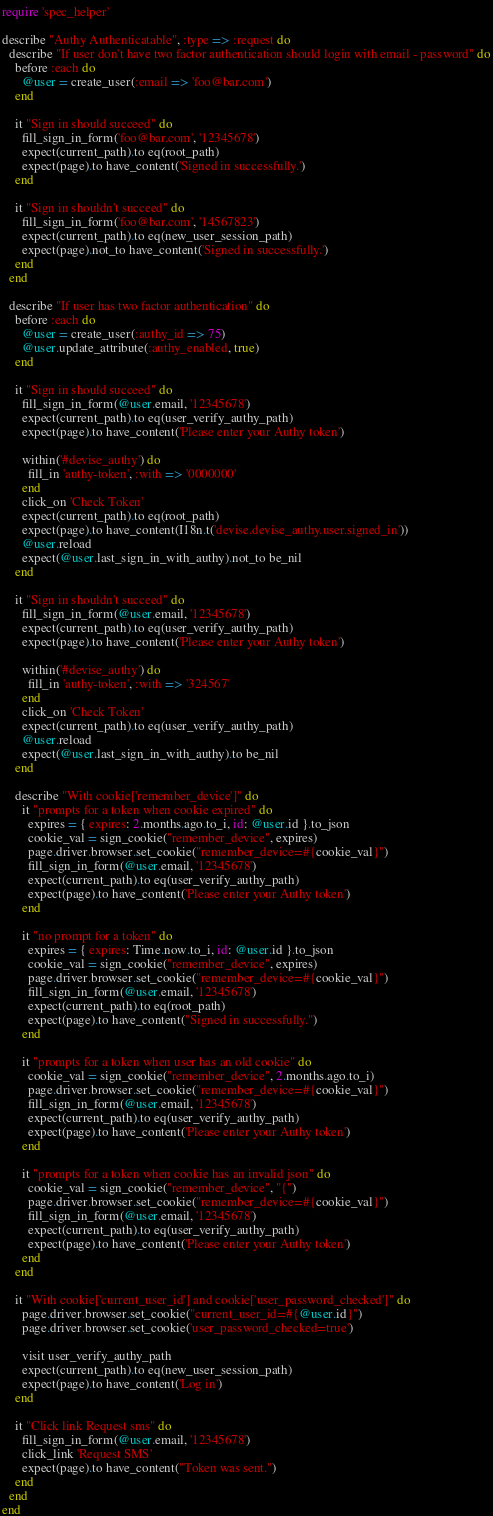<code> <loc_0><loc_0><loc_500><loc_500><_Ruby_>require 'spec_helper'

describe "Authy Authenticatable", :type => :request do
  describe "If user don't have two factor authentication should login with email - password" do
    before :each do
      @user = create_user(:email => 'foo@bar.com')
    end

    it "Sign in should succeed" do
      fill_sign_in_form('foo@bar.com', '12345678')
      expect(current_path).to eq(root_path)
      expect(page).to have_content('Signed in successfully.')
    end

    it "Sign in shouldn't succeed" do
      fill_sign_in_form('foo@bar.com', '14567823')
      expect(current_path).to eq(new_user_session_path)
      expect(page).not_to have_content('Signed in successfully.')
    end
  end

  describe "If user has two factor authentication" do
    before :each do
      @user = create_user(:authy_id => 75)
      @user.update_attribute(:authy_enabled, true)
    end

    it "Sign in should succeed" do
      fill_sign_in_form(@user.email, '12345678')
      expect(current_path).to eq(user_verify_authy_path)
      expect(page).to have_content('Please enter your Authy token')

      within('#devise_authy') do
        fill_in 'authy-token', :with => '0000000'
      end
      click_on 'Check Token'
      expect(current_path).to eq(root_path)
      expect(page).to have_content(I18n.t('devise.devise_authy.user.signed_in'))
      @user.reload
      expect(@user.last_sign_in_with_authy).not_to be_nil
    end

    it "Sign in shouldn't succeed" do
      fill_sign_in_form(@user.email, '12345678')
      expect(current_path).to eq(user_verify_authy_path)
      expect(page).to have_content('Please enter your Authy token')

      within('#devise_authy') do
        fill_in 'authy-token', :with => '324567'
      end
      click_on 'Check Token'
      expect(current_path).to eq(user_verify_authy_path)
      @user.reload
      expect(@user.last_sign_in_with_authy).to be_nil
    end

    describe "With cookie['remember_device']" do
      it "prompts for a token when cookie expired" do
        expires = { expires: 2.months.ago.to_i, id: @user.id }.to_json
        cookie_val = sign_cookie("remember_device", expires)
        page.driver.browser.set_cookie("remember_device=#{cookie_val}")
        fill_sign_in_form(@user.email, '12345678')
        expect(current_path).to eq(user_verify_authy_path)
        expect(page).to have_content('Please enter your Authy token')
      end

      it "no prompt for a token" do
        expires = { expires: Time.now.to_i, id: @user.id }.to_json
        cookie_val = sign_cookie("remember_device", expires)
        page.driver.browser.set_cookie("remember_device=#{cookie_val}")
        fill_sign_in_form(@user.email, '12345678')
        expect(current_path).to eq(root_path)
        expect(page).to have_content("Signed in successfully.")
      end

      it "prompts for a token when user has an old cookie" do
        cookie_val = sign_cookie("remember_device", 2.months.ago.to_i)
        page.driver.browser.set_cookie("remember_device=#{cookie_val}")
        fill_sign_in_form(@user.email, '12345678')
        expect(current_path).to eq(user_verify_authy_path)
        expect(page).to have_content('Please enter your Authy token')
      end

      it "prompts for a token when cookie has an invalid json" do
        cookie_val = sign_cookie("remember_device", "{")
        page.driver.browser.set_cookie("remember_device=#{cookie_val}")
        fill_sign_in_form(@user.email, '12345678')
        expect(current_path).to eq(user_verify_authy_path)
        expect(page).to have_content('Please enter your Authy token')
      end
    end

    it "With cookie['current_user_id'] and cookie['user_password_checked']" do
      page.driver.browser.set_cookie("current_user_id=#{@user.id}")
      page.driver.browser.set_cookie('user_password_checked=true')

      visit user_verify_authy_path
      expect(current_path).to eq(new_user_session_path)
      expect(page).to have_content('Log in')
    end

    it "Click link Request sms" do
      fill_sign_in_form(@user.email, '12345678')
      click_link 'Request SMS'
      expect(page).to have_content("Token was sent.")
    end
  end
end
</code> 